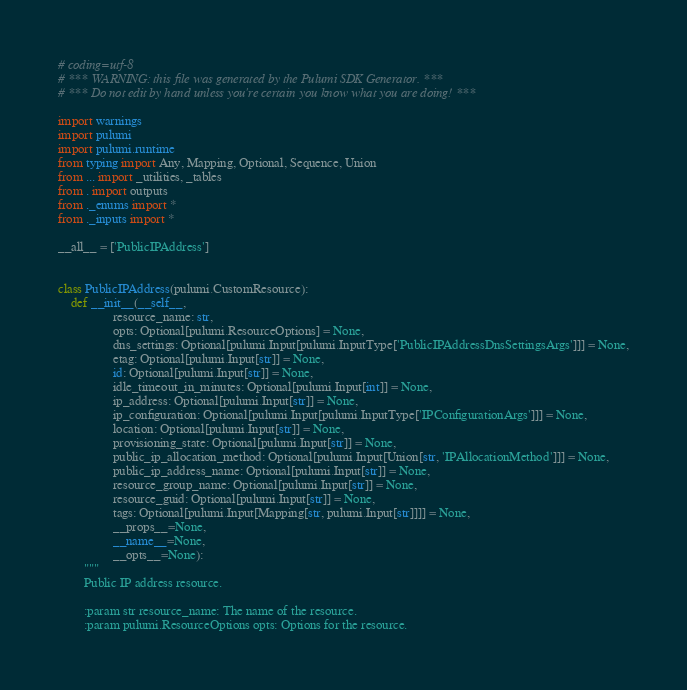<code> <loc_0><loc_0><loc_500><loc_500><_Python_># coding=utf-8
# *** WARNING: this file was generated by the Pulumi SDK Generator. ***
# *** Do not edit by hand unless you're certain you know what you are doing! ***

import warnings
import pulumi
import pulumi.runtime
from typing import Any, Mapping, Optional, Sequence, Union
from ... import _utilities, _tables
from . import outputs
from ._enums import *
from ._inputs import *

__all__ = ['PublicIPAddress']


class PublicIPAddress(pulumi.CustomResource):
    def __init__(__self__,
                 resource_name: str,
                 opts: Optional[pulumi.ResourceOptions] = None,
                 dns_settings: Optional[pulumi.Input[pulumi.InputType['PublicIPAddressDnsSettingsArgs']]] = None,
                 etag: Optional[pulumi.Input[str]] = None,
                 id: Optional[pulumi.Input[str]] = None,
                 idle_timeout_in_minutes: Optional[pulumi.Input[int]] = None,
                 ip_address: Optional[pulumi.Input[str]] = None,
                 ip_configuration: Optional[pulumi.Input[pulumi.InputType['IPConfigurationArgs']]] = None,
                 location: Optional[pulumi.Input[str]] = None,
                 provisioning_state: Optional[pulumi.Input[str]] = None,
                 public_ip_allocation_method: Optional[pulumi.Input[Union[str, 'IPAllocationMethod']]] = None,
                 public_ip_address_name: Optional[pulumi.Input[str]] = None,
                 resource_group_name: Optional[pulumi.Input[str]] = None,
                 resource_guid: Optional[pulumi.Input[str]] = None,
                 tags: Optional[pulumi.Input[Mapping[str, pulumi.Input[str]]]] = None,
                 __props__=None,
                 __name__=None,
                 __opts__=None):
        """
        Public IP address resource.

        :param str resource_name: The name of the resource.
        :param pulumi.ResourceOptions opts: Options for the resource.</code> 